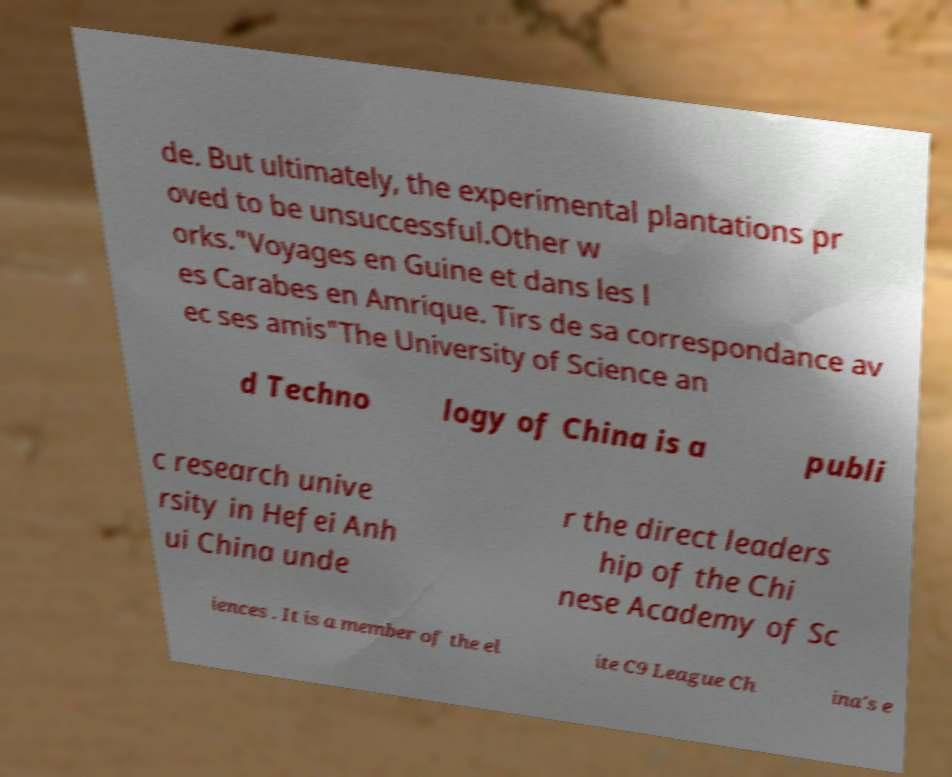Could you extract and type out the text from this image? de. But ultimately, the experimental plantations pr oved to be unsuccessful.Other w orks."Voyages en Guine et dans les l es Carabes en Amrique. Tirs de sa correspondance av ec ses amis"The University of Science an d Techno logy of China is a publi c research unive rsity in Hefei Anh ui China unde r the direct leaders hip of the Chi nese Academy of Sc iences . It is a member of the el ite C9 League Ch ina's e 